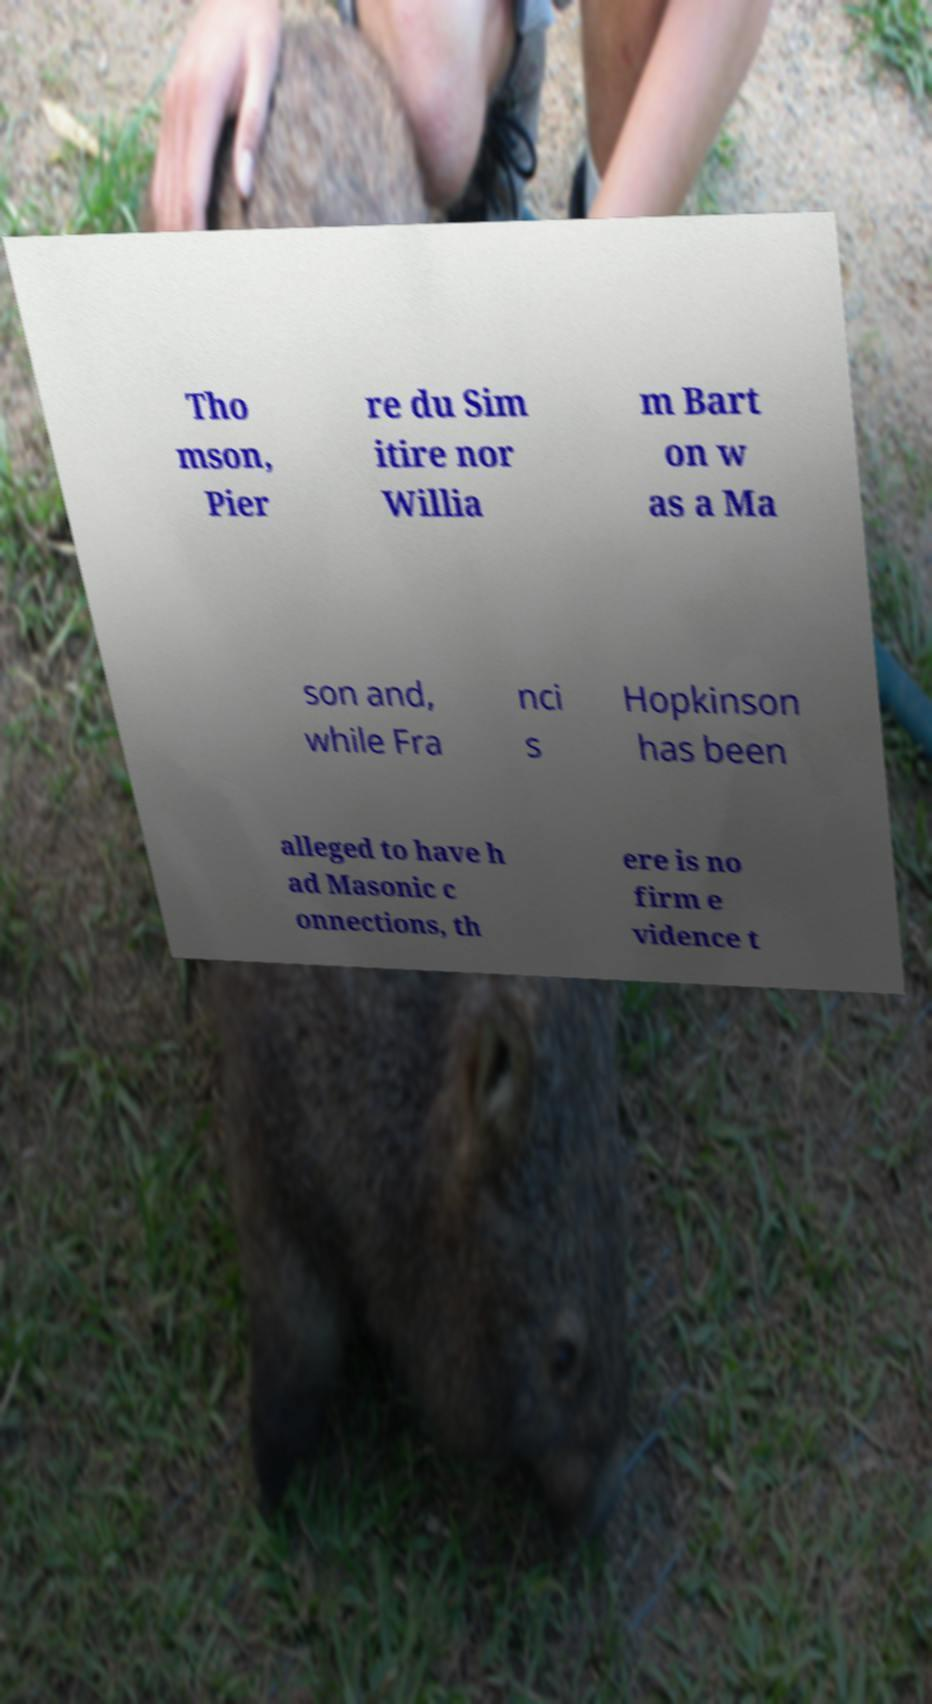Please identify and transcribe the text found in this image. Tho mson, Pier re du Sim itire nor Willia m Bart on w as a Ma son and, while Fra nci s Hopkinson has been alleged to have h ad Masonic c onnections, th ere is no firm e vidence t 